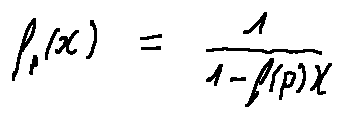<formula> <loc_0><loc_0><loc_500><loc_500>f _ { p } ( X ) = \frac { 1 } { 1 - f ( p ) X }</formula> 